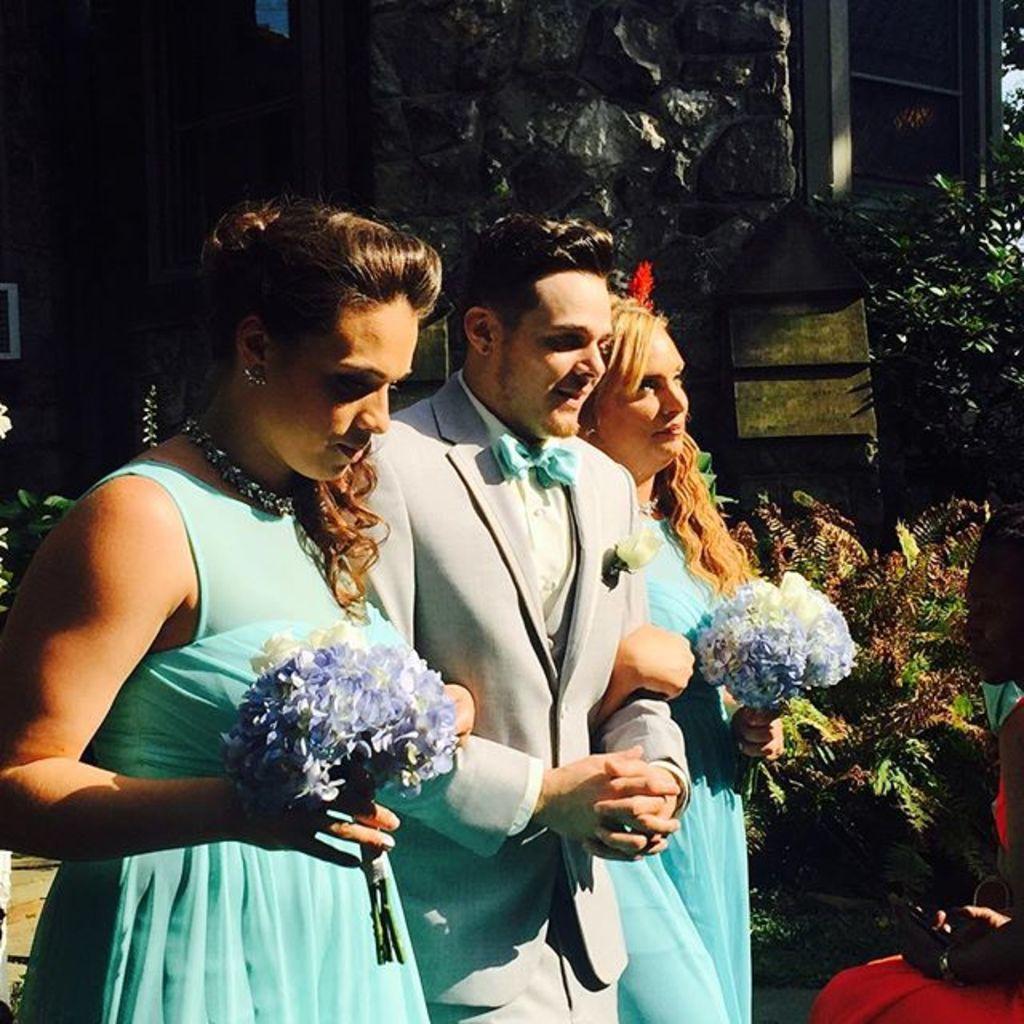Describe this image in one or two sentences. There are three persons standing at the bottom of this image. The two women are holdings some flowers. We can see there are some plants in the background and there is a house at the top of this image. 